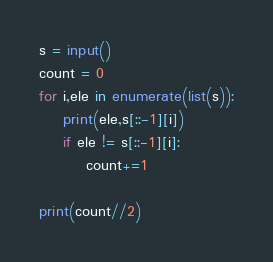<code> <loc_0><loc_0><loc_500><loc_500><_Python_>s = input()
count = 0
for i,ele in enumerate(list(s)):
    print(ele,s[::-1][i])
    if ele != s[::-1][i]:
        count+=1

print(count//2)</code> 